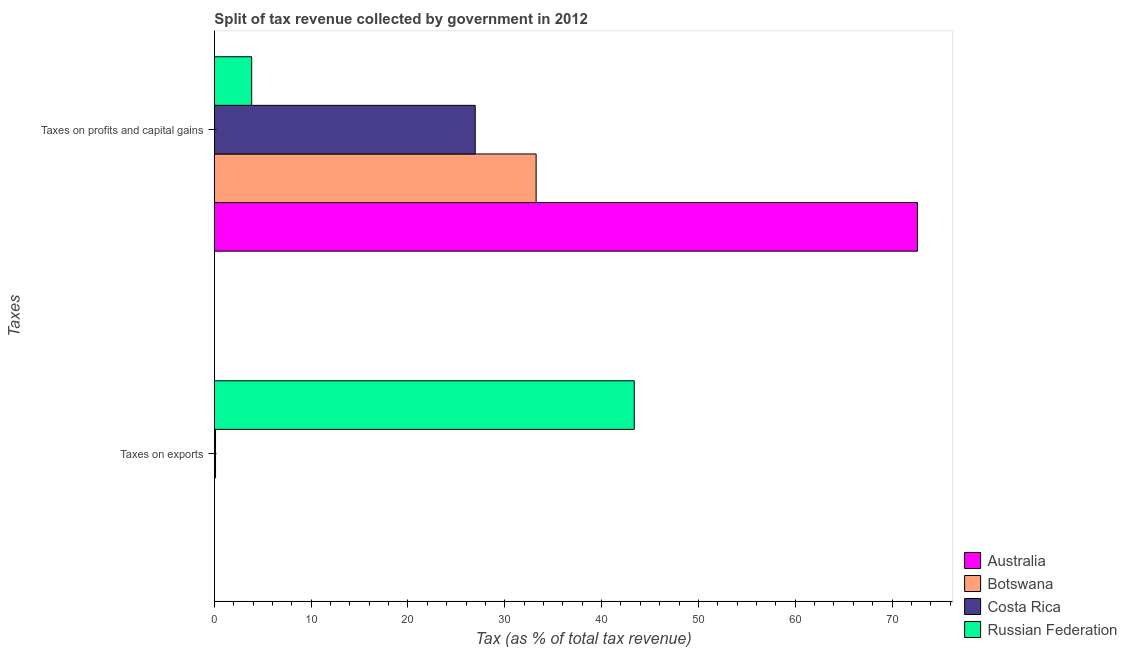Are the number of bars per tick equal to the number of legend labels?
Make the answer very short. Yes. Are the number of bars on each tick of the Y-axis equal?
Keep it short and to the point. Yes. How many bars are there on the 1st tick from the bottom?
Give a very brief answer. 4. What is the label of the 1st group of bars from the top?
Your answer should be very brief. Taxes on profits and capital gains. What is the percentage of revenue obtained from taxes on profits and capital gains in Australia?
Ensure brevity in your answer.  72.62. Across all countries, what is the maximum percentage of revenue obtained from taxes on profits and capital gains?
Keep it short and to the point. 72.62. Across all countries, what is the minimum percentage of revenue obtained from taxes on profits and capital gains?
Provide a succinct answer. 3.85. In which country was the percentage of revenue obtained from taxes on profits and capital gains maximum?
Provide a succinct answer. Australia. In which country was the percentage of revenue obtained from taxes on profits and capital gains minimum?
Your answer should be very brief. Russian Federation. What is the total percentage of revenue obtained from taxes on exports in the graph?
Your response must be concise. 43.51. What is the difference between the percentage of revenue obtained from taxes on profits and capital gains in Australia and that in Botswana?
Ensure brevity in your answer.  39.39. What is the difference between the percentage of revenue obtained from taxes on exports in Botswana and the percentage of revenue obtained from taxes on profits and capital gains in Russian Federation?
Your answer should be very brief. -3.85. What is the average percentage of revenue obtained from taxes on profits and capital gains per country?
Keep it short and to the point. 34.17. What is the difference between the percentage of revenue obtained from taxes on profits and capital gains and percentage of revenue obtained from taxes on exports in Russian Federation?
Your response must be concise. -39.52. In how many countries, is the percentage of revenue obtained from taxes on profits and capital gains greater than 22 %?
Provide a short and direct response. 3. What is the ratio of the percentage of revenue obtained from taxes on exports in Australia to that in Russian Federation?
Offer a terse response. 8.703650756223647e-5. In how many countries, is the percentage of revenue obtained from taxes on profits and capital gains greater than the average percentage of revenue obtained from taxes on profits and capital gains taken over all countries?
Provide a succinct answer. 1. What does the 1st bar from the top in Taxes on profits and capital gains represents?
Your answer should be very brief. Russian Federation. What does the 4th bar from the bottom in Taxes on exports represents?
Your answer should be very brief. Russian Federation. How many bars are there?
Ensure brevity in your answer.  8. Are all the bars in the graph horizontal?
Ensure brevity in your answer.  Yes. How many countries are there in the graph?
Your answer should be compact. 4. What is the difference between two consecutive major ticks on the X-axis?
Your response must be concise. 10. Are the values on the major ticks of X-axis written in scientific E-notation?
Keep it short and to the point. No. Where does the legend appear in the graph?
Make the answer very short. Bottom right. How many legend labels are there?
Offer a terse response. 4. How are the legend labels stacked?
Your answer should be compact. Vertical. What is the title of the graph?
Your answer should be compact. Split of tax revenue collected by government in 2012. Does "Uganda" appear as one of the legend labels in the graph?
Provide a succinct answer. No. What is the label or title of the X-axis?
Make the answer very short. Tax (as % of total tax revenue). What is the label or title of the Y-axis?
Ensure brevity in your answer.  Taxes. What is the Tax (as % of total tax revenue) in Australia in Taxes on exports?
Provide a short and direct response. 0. What is the Tax (as % of total tax revenue) in Botswana in Taxes on exports?
Your response must be concise. 0.01. What is the Tax (as % of total tax revenue) of Costa Rica in Taxes on exports?
Give a very brief answer. 0.12. What is the Tax (as % of total tax revenue) of Russian Federation in Taxes on exports?
Provide a succinct answer. 43.37. What is the Tax (as % of total tax revenue) of Australia in Taxes on profits and capital gains?
Provide a succinct answer. 72.62. What is the Tax (as % of total tax revenue) of Botswana in Taxes on profits and capital gains?
Your answer should be compact. 33.24. What is the Tax (as % of total tax revenue) of Costa Rica in Taxes on profits and capital gains?
Offer a very short reply. 26.95. What is the Tax (as % of total tax revenue) in Russian Federation in Taxes on profits and capital gains?
Provide a succinct answer. 3.85. Across all Taxes, what is the maximum Tax (as % of total tax revenue) in Australia?
Make the answer very short. 72.62. Across all Taxes, what is the maximum Tax (as % of total tax revenue) of Botswana?
Give a very brief answer. 33.24. Across all Taxes, what is the maximum Tax (as % of total tax revenue) in Costa Rica?
Provide a succinct answer. 26.95. Across all Taxes, what is the maximum Tax (as % of total tax revenue) in Russian Federation?
Offer a very short reply. 43.37. Across all Taxes, what is the minimum Tax (as % of total tax revenue) of Australia?
Keep it short and to the point. 0. Across all Taxes, what is the minimum Tax (as % of total tax revenue) of Botswana?
Your response must be concise. 0.01. Across all Taxes, what is the minimum Tax (as % of total tax revenue) in Costa Rica?
Ensure brevity in your answer.  0.12. Across all Taxes, what is the minimum Tax (as % of total tax revenue) in Russian Federation?
Make the answer very short. 3.85. What is the total Tax (as % of total tax revenue) in Australia in the graph?
Your response must be concise. 72.63. What is the total Tax (as % of total tax revenue) of Botswana in the graph?
Provide a succinct answer. 33.25. What is the total Tax (as % of total tax revenue) in Costa Rica in the graph?
Your response must be concise. 27.07. What is the total Tax (as % of total tax revenue) in Russian Federation in the graph?
Ensure brevity in your answer.  47.23. What is the difference between the Tax (as % of total tax revenue) in Australia in Taxes on exports and that in Taxes on profits and capital gains?
Provide a succinct answer. -72.62. What is the difference between the Tax (as % of total tax revenue) in Botswana in Taxes on exports and that in Taxes on profits and capital gains?
Your answer should be very brief. -33.23. What is the difference between the Tax (as % of total tax revenue) of Costa Rica in Taxes on exports and that in Taxes on profits and capital gains?
Give a very brief answer. -26.82. What is the difference between the Tax (as % of total tax revenue) of Russian Federation in Taxes on exports and that in Taxes on profits and capital gains?
Provide a succinct answer. 39.52. What is the difference between the Tax (as % of total tax revenue) of Australia in Taxes on exports and the Tax (as % of total tax revenue) of Botswana in Taxes on profits and capital gains?
Ensure brevity in your answer.  -33.23. What is the difference between the Tax (as % of total tax revenue) of Australia in Taxes on exports and the Tax (as % of total tax revenue) of Costa Rica in Taxes on profits and capital gains?
Provide a succinct answer. -26.94. What is the difference between the Tax (as % of total tax revenue) in Australia in Taxes on exports and the Tax (as % of total tax revenue) in Russian Federation in Taxes on profits and capital gains?
Provide a short and direct response. -3.85. What is the difference between the Tax (as % of total tax revenue) in Botswana in Taxes on exports and the Tax (as % of total tax revenue) in Costa Rica in Taxes on profits and capital gains?
Offer a very short reply. -26.94. What is the difference between the Tax (as % of total tax revenue) in Botswana in Taxes on exports and the Tax (as % of total tax revenue) in Russian Federation in Taxes on profits and capital gains?
Ensure brevity in your answer.  -3.85. What is the difference between the Tax (as % of total tax revenue) of Costa Rica in Taxes on exports and the Tax (as % of total tax revenue) of Russian Federation in Taxes on profits and capital gains?
Your response must be concise. -3.73. What is the average Tax (as % of total tax revenue) of Australia per Taxes?
Your response must be concise. 36.31. What is the average Tax (as % of total tax revenue) in Botswana per Taxes?
Keep it short and to the point. 16.62. What is the average Tax (as % of total tax revenue) of Costa Rica per Taxes?
Your answer should be very brief. 13.53. What is the average Tax (as % of total tax revenue) in Russian Federation per Taxes?
Your answer should be compact. 23.61. What is the difference between the Tax (as % of total tax revenue) of Australia and Tax (as % of total tax revenue) of Botswana in Taxes on exports?
Make the answer very short. -0. What is the difference between the Tax (as % of total tax revenue) in Australia and Tax (as % of total tax revenue) in Costa Rica in Taxes on exports?
Make the answer very short. -0.12. What is the difference between the Tax (as % of total tax revenue) in Australia and Tax (as % of total tax revenue) in Russian Federation in Taxes on exports?
Provide a short and direct response. -43.37. What is the difference between the Tax (as % of total tax revenue) of Botswana and Tax (as % of total tax revenue) of Costa Rica in Taxes on exports?
Ensure brevity in your answer.  -0.12. What is the difference between the Tax (as % of total tax revenue) of Botswana and Tax (as % of total tax revenue) of Russian Federation in Taxes on exports?
Your answer should be compact. -43.37. What is the difference between the Tax (as % of total tax revenue) in Costa Rica and Tax (as % of total tax revenue) in Russian Federation in Taxes on exports?
Your response must be concise. -43.25. What is the difference between the Tax (as % of total tax revenue) in Australia and Tax (as % of total tax revenue) in Botswana in Taxes on profits and capital gains?
Give a very brief answer. 39.39. What is the difference between the Tax (as % of total tax revenue) in Australia and Tax (as % of total tax revenue) in Costa Rica in Taxes on profits and capital gains?
Your response must be concise. 45.68. What is the difference between the Tax (as % of total tax revenue) in Australia and Tax (as % of total tax revenue) in Russian Federation in Taxes on profits and capital gains?
Your answer should be compact. 68.77. What is the difference between the Tax (as % of total tax revenue) of Botswana and Tax (as % of total tax revenue) of Costa Rica in Taxes on profits and capital gains?
Make the answer very short. 6.29. What is the difference between the Tax (as % of total tax revenue) in Botswana and Tax (as % of total tax revenue) in Russian Federation in Taxes on profits and capital gains?
Provide a succinct answer. 29.38. What is the difference between the Tax (as % of total tax revenue) in Costa Rica and Tax (as % of total tax revenue) in Russian Federation in Taxes on profits and capital gains?
Your answer should be very brief. 23.09. What is the ratio of the Tax (as % of total tax revenue) in Costa Rica in Taxes on exports to that in Taxes on profits and capital gains?
Ensure brevity in your answer.  0. What is the ratio of the Tax (as % of total tax revenue) in Russian Federation in Taxes on exports to that in Taxes on profits and capital gains?
Provide a succinct answer. 11.25. What is the difference between the highest and the second highest Tax (as % of total tax revenue) of Australia?
Give a very brief answer. 72.62. What is the difference between the highest and the second highest Tax (as % of total tax revenue) in Botswana?
Your answer should be very brief. 33.23. What is the difference between the highest and the second highest Tax (as % of total tax revenue) in Costa Rica?
Your response must be concise. 26.82. What is the difference between the highest and the second highest Tax (as % of total tax revenue) of Russian Federation?
Give a very brief answer. 39.52. What is the difference between the highest and the lowest Tax (as % of total tax revenue) in Australia?
Keep it short and to the point. 72.62. What is the difference between the highest and the lowest Tax (as % of total tax revenue) of Botswana?
Provide a short and direct response. 33.23. What is the difference between the highest and the lowest Tax (as % of total tax revenue) in Costa Rica?
Provide a succinct answer. 26.82. What is the difference between the highest and the lowest Tax (as % of total tax revenue) of Russian Federation?
Offer a terse response. 39.52. 